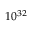Convert formula to latex. <formula><loc_0><loc_0><loc_500><loc_500>1 0 ^ { 3 2 }</formula> 